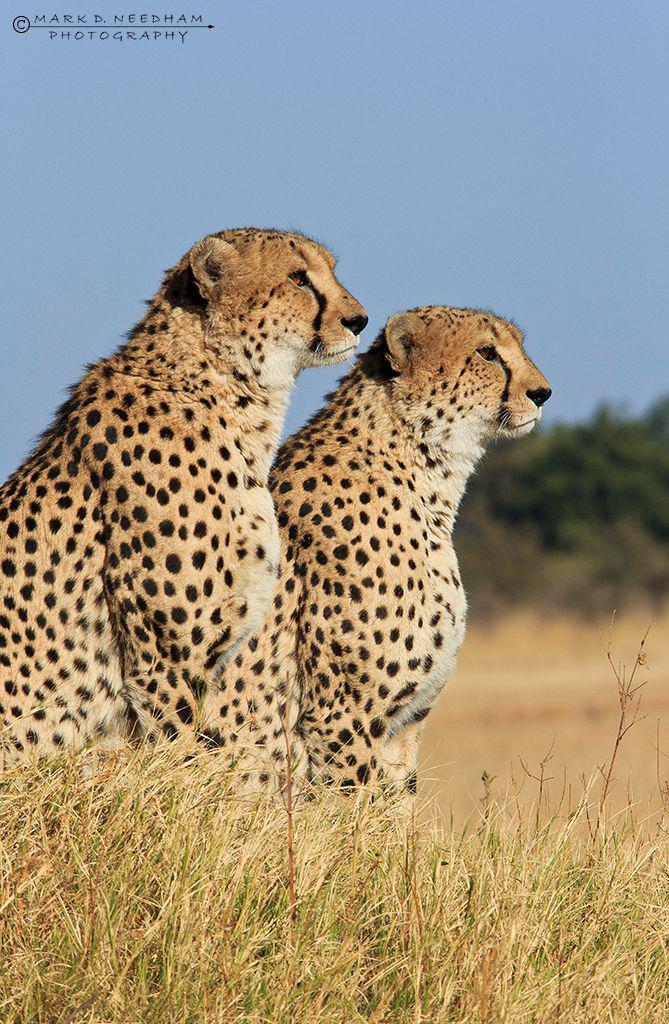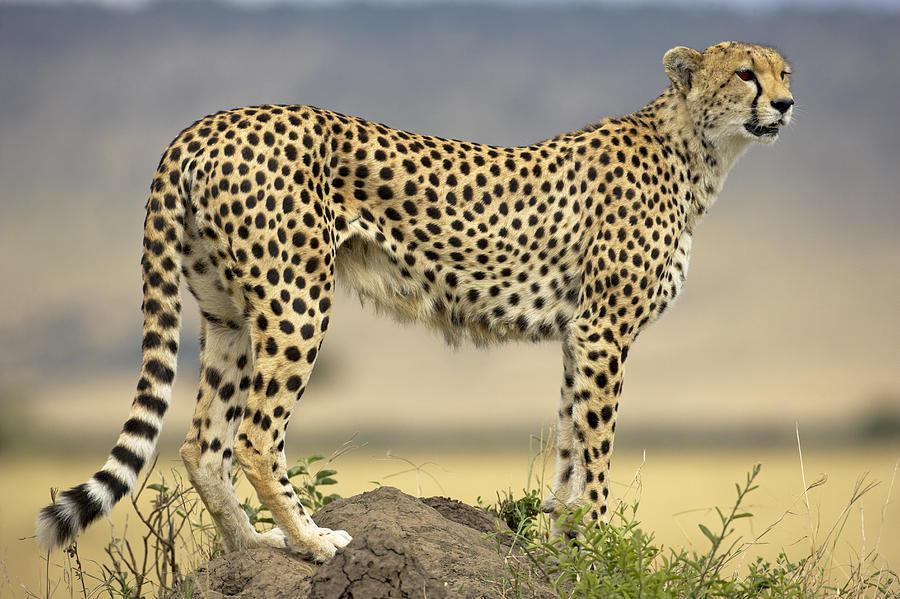The first image is the image on the left, the second image is the image on the right. Considering the images on both sides, is "The left image contains exactly three cheetahs, and the right image includes an adult cheetah with its back to the camera and its head turned sharply to gaze right." valid? Answer yes or no. No. The first image is the image on the left, the second image is the image on the right. For the images shown, is this caption "The right image contains exactly one cheetah." true? Answer yes or no. Yes. 